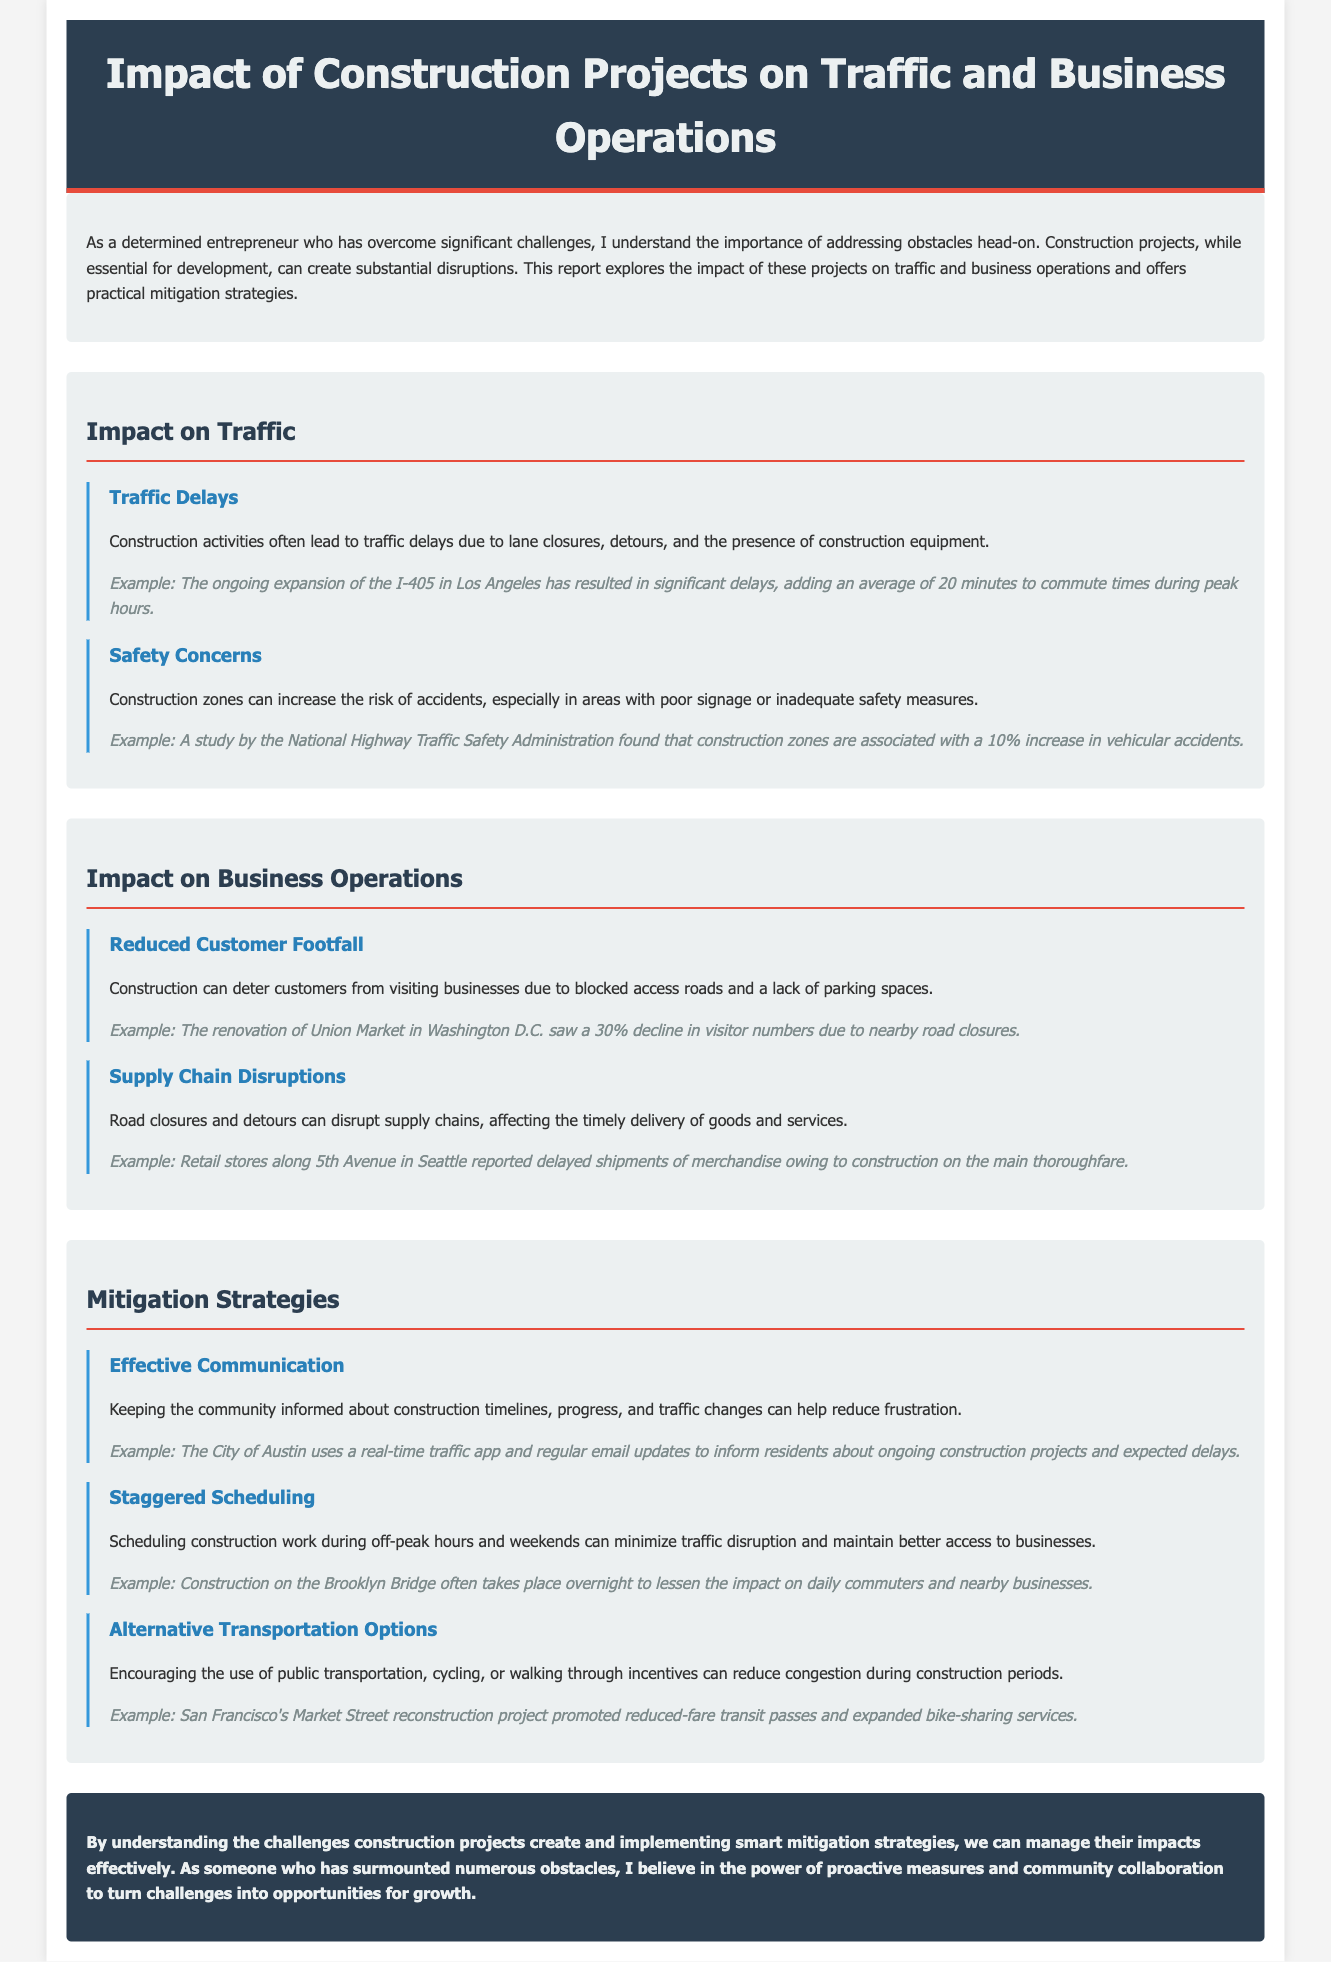What is the title of the report? The title of the report is stated in the header of the document.
Answer: Impact of Construction Projects on Traffic and Business Operations What traffic impact leads to safety concerns? The report mentions that construction zones can increase the risk of accidents.
Answer: Risk of accidents What percentage increase in accidents is associated with construction zones? The document cites a specific percentage regarding accidents in construction zones.
Answer: 10% What type of business impact is caused by reduced customer footfall? The report describes how construction affects businesses, particularly in access to customers.
Answer: Blocked access roads What is one example of an effective mitigation strategy mentioned? The document lists specific strategies, including effective communication with the community.
Answer: Effective communication During which hours should construction work be scheduled to minimize disruption? The report suggests specific scheduling to mitigate impacts on traffic and business access.
Answer: Off-peak hours What city uses a real-time traffic app to keep residents informed? The document provides an example of a city’s communication strategy during construction projects.
Answer: City of Austin What construction project caused a 30% decline in visitor numbers? The document gives a specific example of a project affecting visitor traffic to a business.
Answer: Renovation of Union Market What is the main theme of the report? The overarching theme of the report is discussed in the introduction and conclusion sections.
Answer: Impact and mitigation of construction projects 